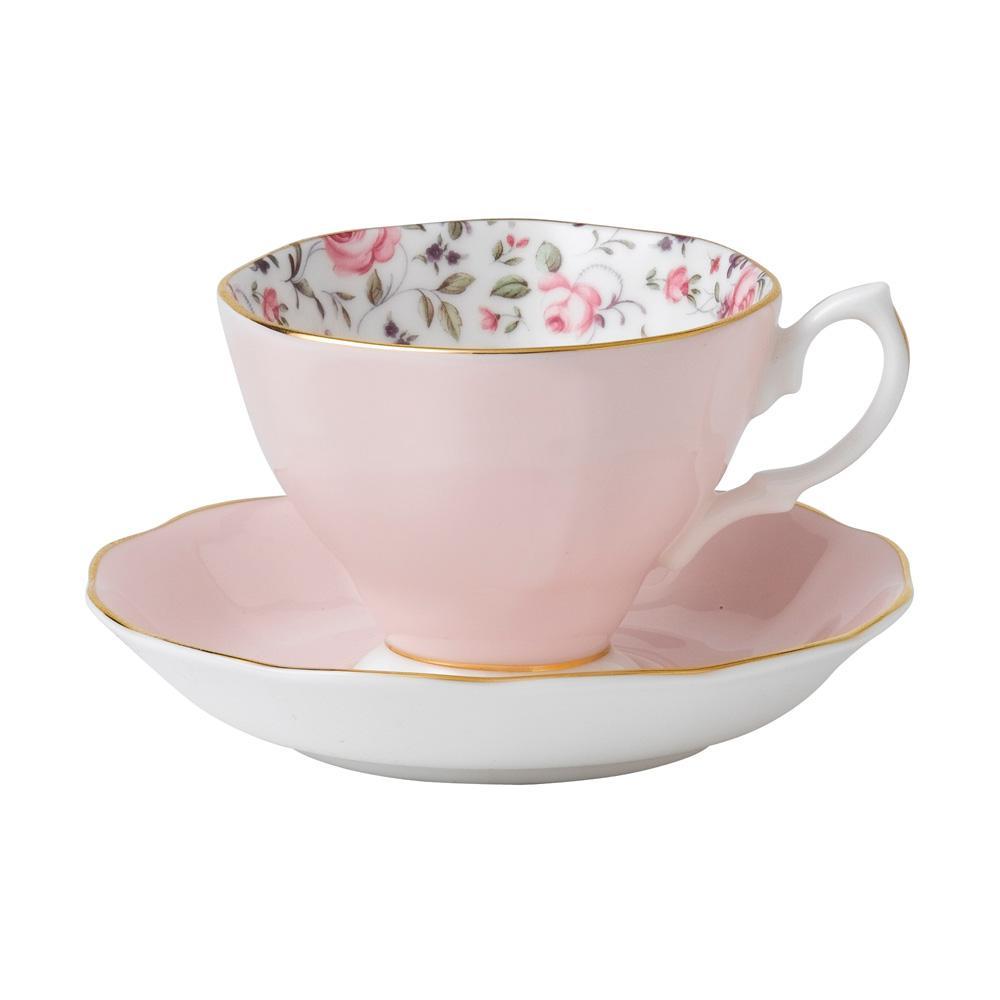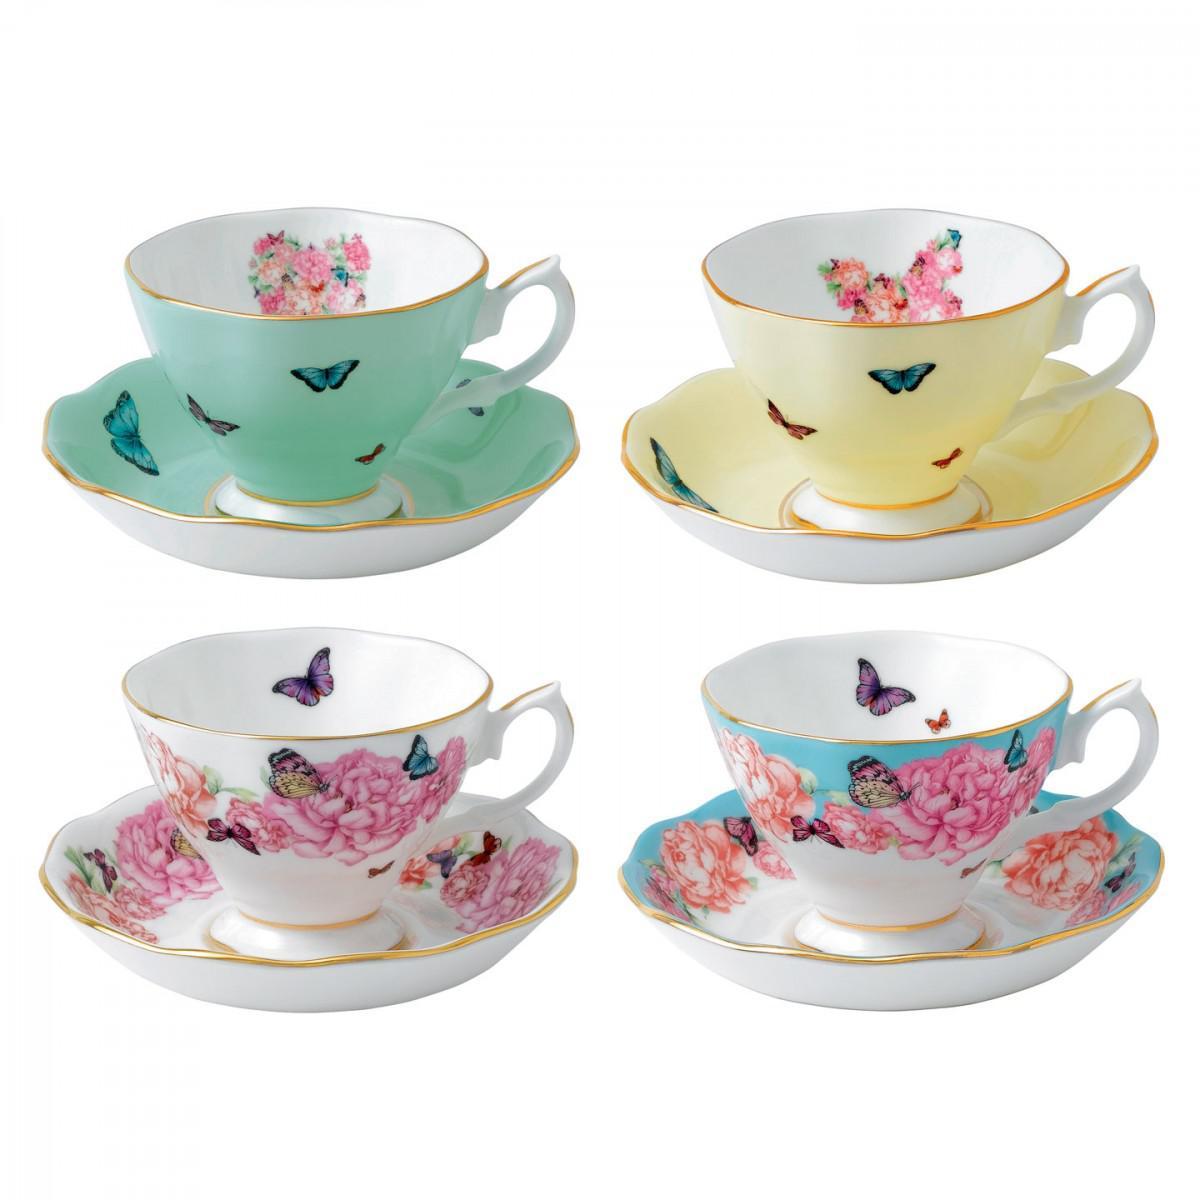The first image is the image on the left, the second image is the image on the right. Evaluate the accuracy of this statement regarding the images: "There are two teacup and saucer sets". Is it true? Answer yes or no. No. The first image is the image on the left, the second image is the image on the right. Evaluate the accuracy of this statement regarding the images: "An image contains exactly four cups on saucers.". Is it true? Answer yes or no. Yes. 